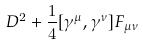<formula> <loc_0><loc_0><loc_500><loc_500>D ^ { 2 } + \frac { 1 } { 4 } [ \gamma ^ { \mu } , \gamma ^ { \nu } ] F _ { \mu \nu }</formula> 